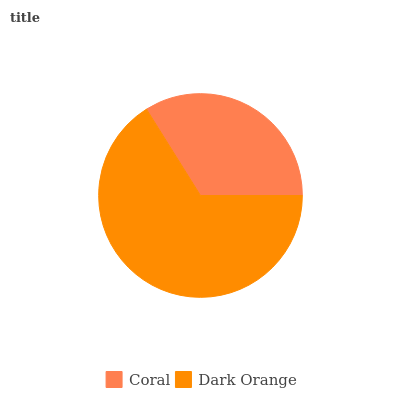Is Coral the minimum?
Answer yes or no. Yes. Is Dark Orange the maximum?
Answer yes or no. Yes. Is Dark Orange the minimum?
Answer yes or no. No. Is Dark Orange greater than Coral?
Answer yes or no. Yes. Is Coral less than Dark Orange?
Answer yes or no. Yes. Is Coral greater than Dark Orange?
Answer yes or no. No. Is Dark Orange less than Coral?
Answer yes or no. No. Is Dark Orange the high median?
Answer yes or no. Yes. Is Coral the low median?
Answer yes or no. Yes. Is Coral the high median?
Answer yes or no. No. Is Dark Orange the low median?
Answer yes or no. No. 